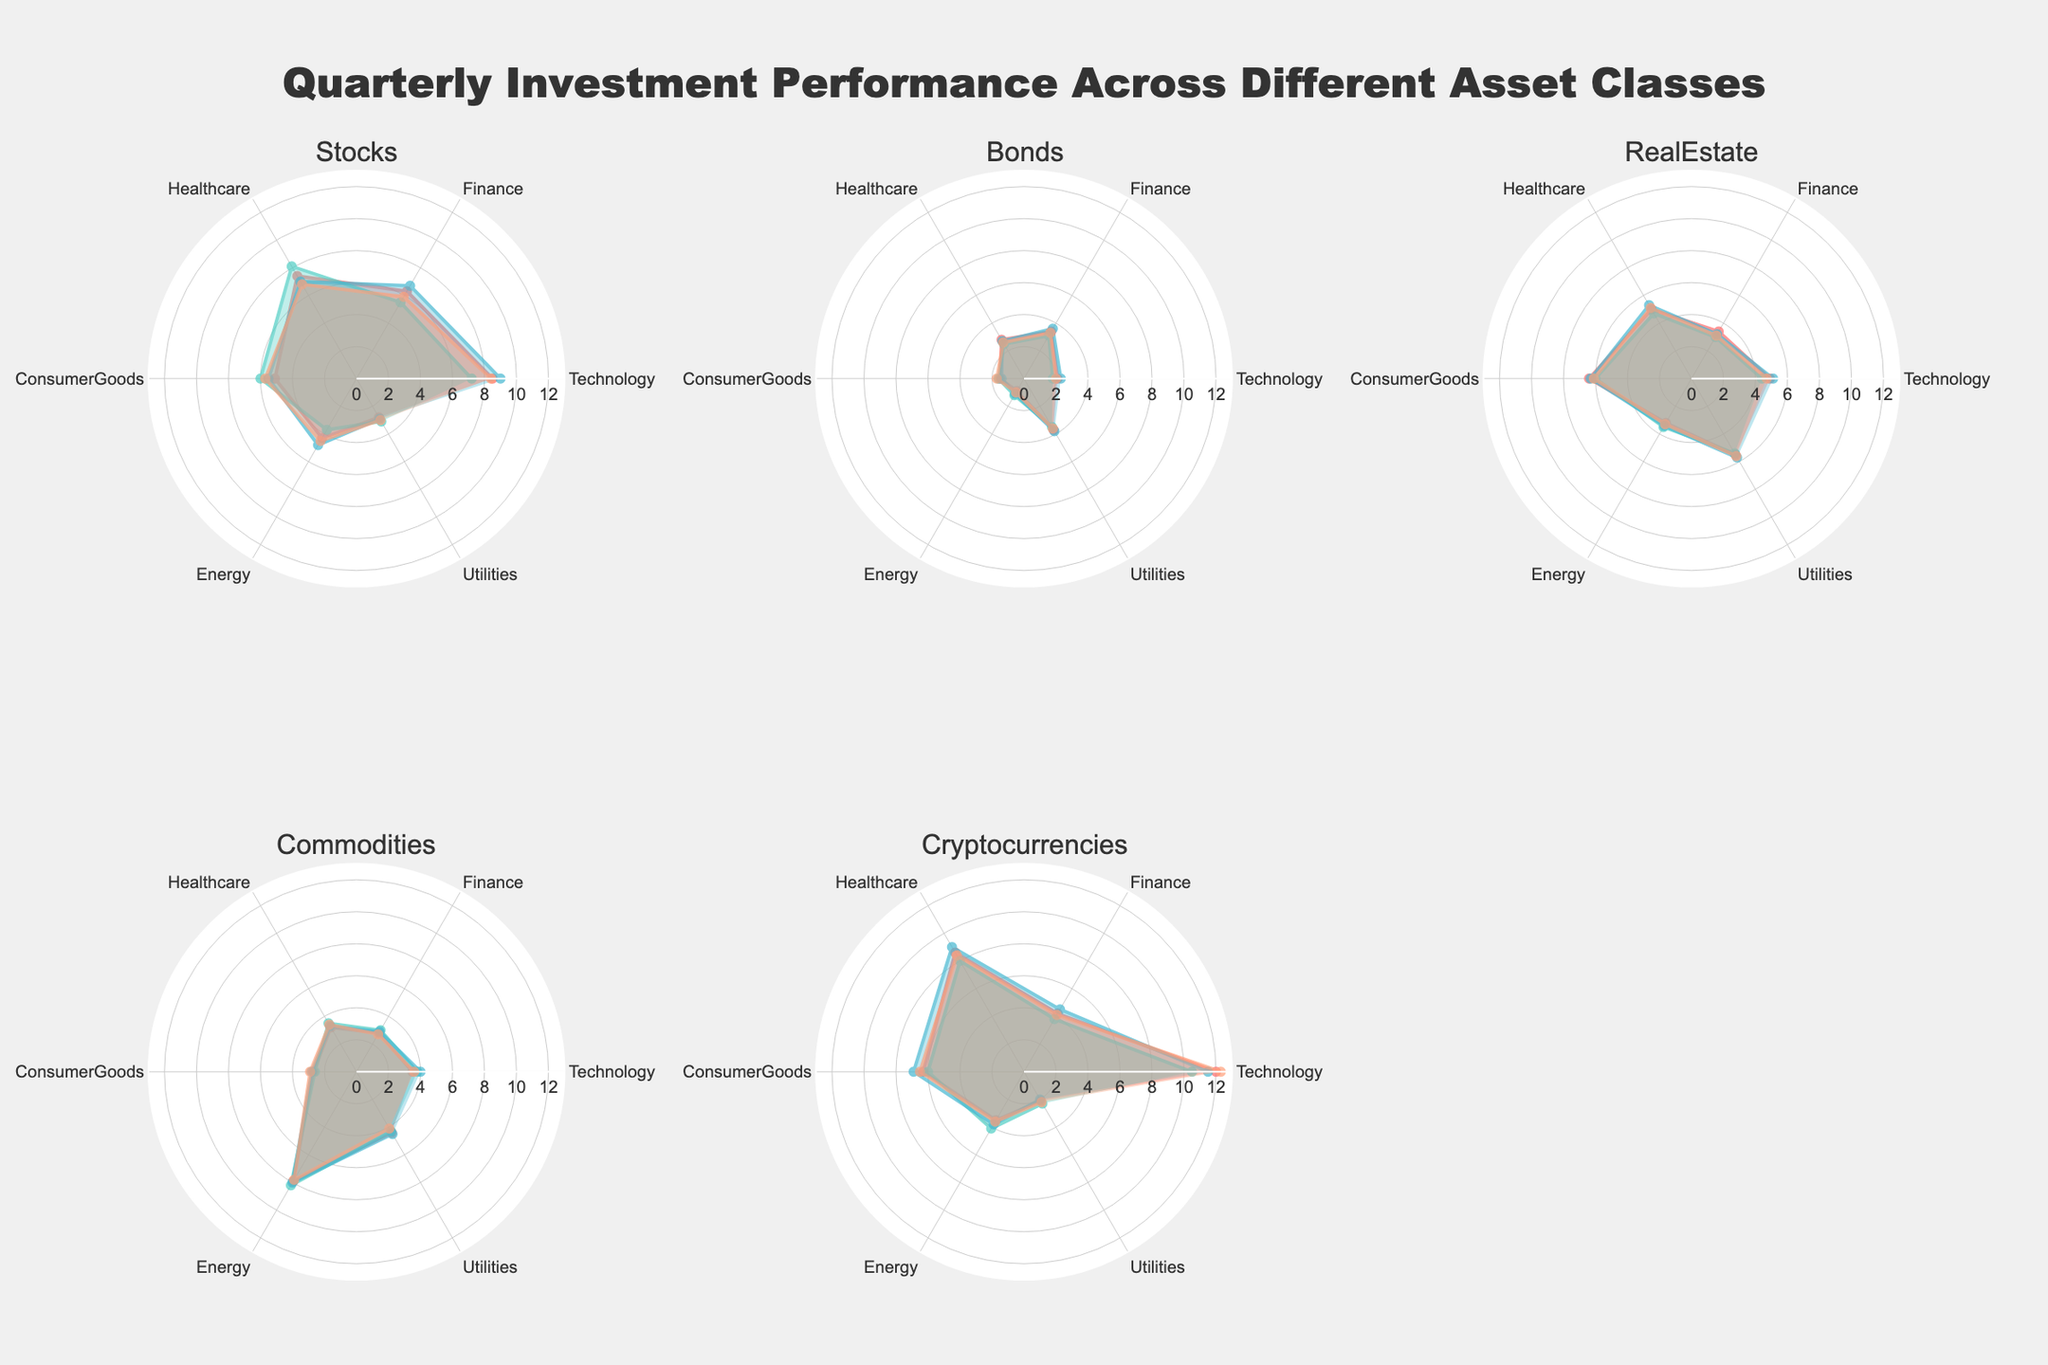Which asset class shows the highest performance in Q3? Looking at the polar charts, in Q3, Cryptocurrencies show the highest performance among all asset classes.
Answer: Cryptocurrencies Which asset class has the most consistent performance across all quarters? By observing the charts, RealEstate shows relatively consistent values across all quarters with slight variations, ensuring stable performance.
Answer: RealEstate How does the performance of Technology stocks change from Q1 to Q4? In the polar chart for Stocks, Technology starts at 8.5 in Q1, increases to 9.0 in Q3, and slightly drops to 8.4 in Q4.
Answer: Slight increase followed by a slight decrease Among the asset classes, which one has the least performance in Q1? Referring to the Q1 data points across all asset classes, Bonds are the least performing with values ranging from 0.9 up to 3.7.
Answer: Bonds Which sector has the highest value in Q2 for Commodities? From the polar chart for Commodities in Q2, Energy shows the highest value among all sectors.
Answer: Energy What is the average performance of Utilities across all asset classes in Q4? For Q4, summing the Utilities values from Stocks (3.0), Bonds (3.6), RealEstate (5.6), Commodities (4.1), and Cryptocurrencies (2.2) and dividing by 5 gives an average of (3.0+3.6+5.6+4.1+2.2)/5 = 3.7.
Answer: 3.7 Which asset class has the highest overall performance in Technology sector? From the Technology sector values, Cryptocurrencies have the highest values in every quarter, outperforming other classes.
Answer: Cryptocurrencies Compare the performance of Finance sector between Stocks and Bonds in Q2. In Q2, Finance for Stocks is 5.5 and for Bonds is 3.1. Stocks perform better than Bonds in Finance.
Answer: Stocks perform better Which sector shows the most variation in Bond performance across all quarters? For Bonds, the sector showing the most variation is Utilities, with values ranging from 3.5 to 3.8.
Answer: Utilities In terms of Energy sector, which quarter shows the maximum performance across all asset classes? Looking at the Energy values, Q2 and Q4 show the highest performance in the Commodities class with values of 8.2 and 7.8 respectively.
Answer: Q2 